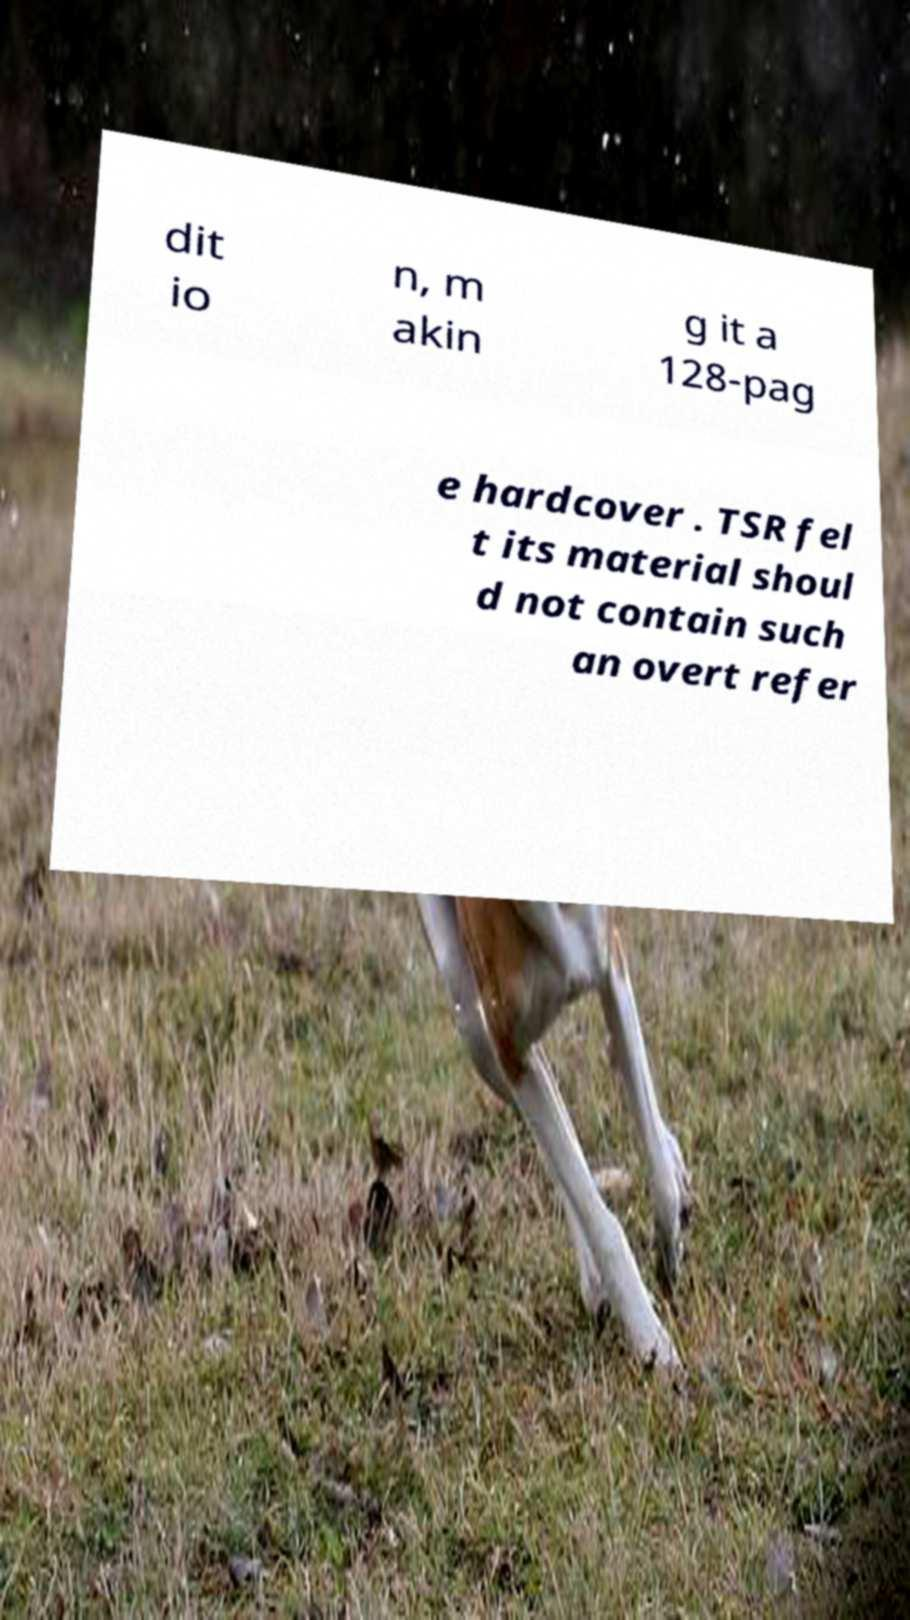For documentation purposes, I need the text within this image transcribed. Could you provide that? dit io n, m akin g it a 128-pag e hardcover . TSR fel t its material shoul d not contain such an overt refer 